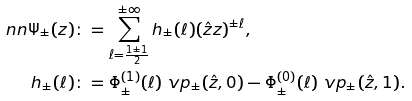Convert formula to latex. <formula><loc_0><loc_0><loc_500><loc_500>\ n n \Psi _ { \pm } ( z ) & \colon = \sum _ { \ell = \frac { 1 \pm 1 } { 2 } } ^ { \pm \infty } h _ { \pm } ( \ell ) ( \hat { z } z ) ^ { \pm \ell } , \\ h _ { \pm } ( \ell ) & \colon = \Phi _ { \pm } ^ { ( 1 ) } ( \ell ) \ v p _ { \pm } ( \hat { z } , 0 ) - \Phi _ { \pm } ^ { ( 0 ) } ( \ell ) \ v p _ { \pm } ( \hat { z } , 1 ) .</formula> 